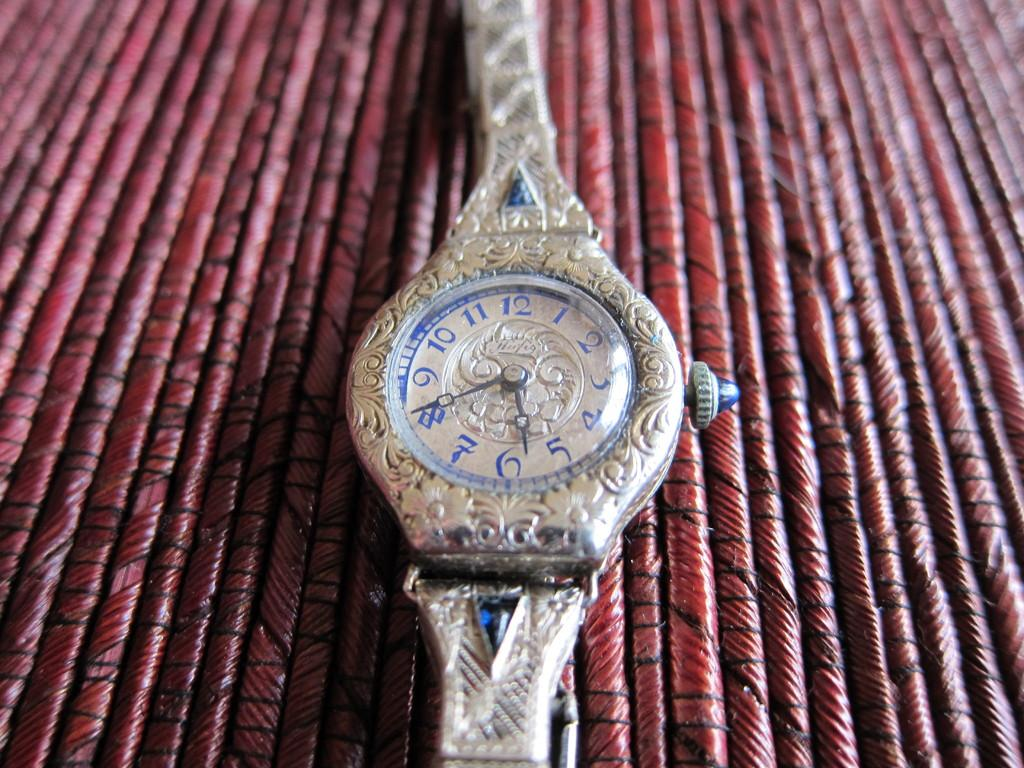<image>
Summarize the visual content of the image. A fancy lady's watch has a brand name that starts with H. 